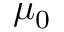Convert formula to latex. <formula><loc_0><loc_0><loc_500><loc_500>\mu _ { 0 }</formula> 